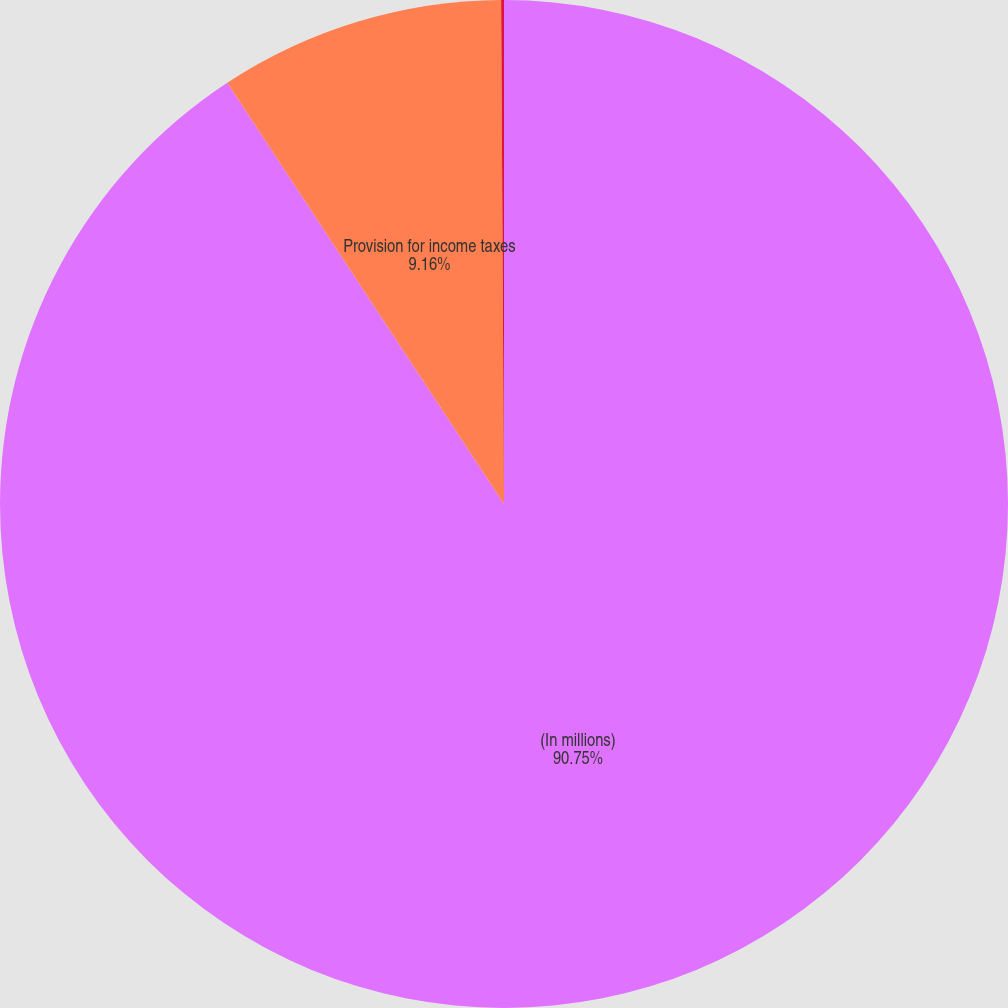Convert chart. <chart><loc_0><loc_0><loc_500><loc_500><pie_chart><fcel>(In millions)<fcel>Provision for income taxes<fcel>Aggregate foreign currency<nl><fcel>90.75%<fcel>9.16%<fcel>0.09%<nl></chart> 